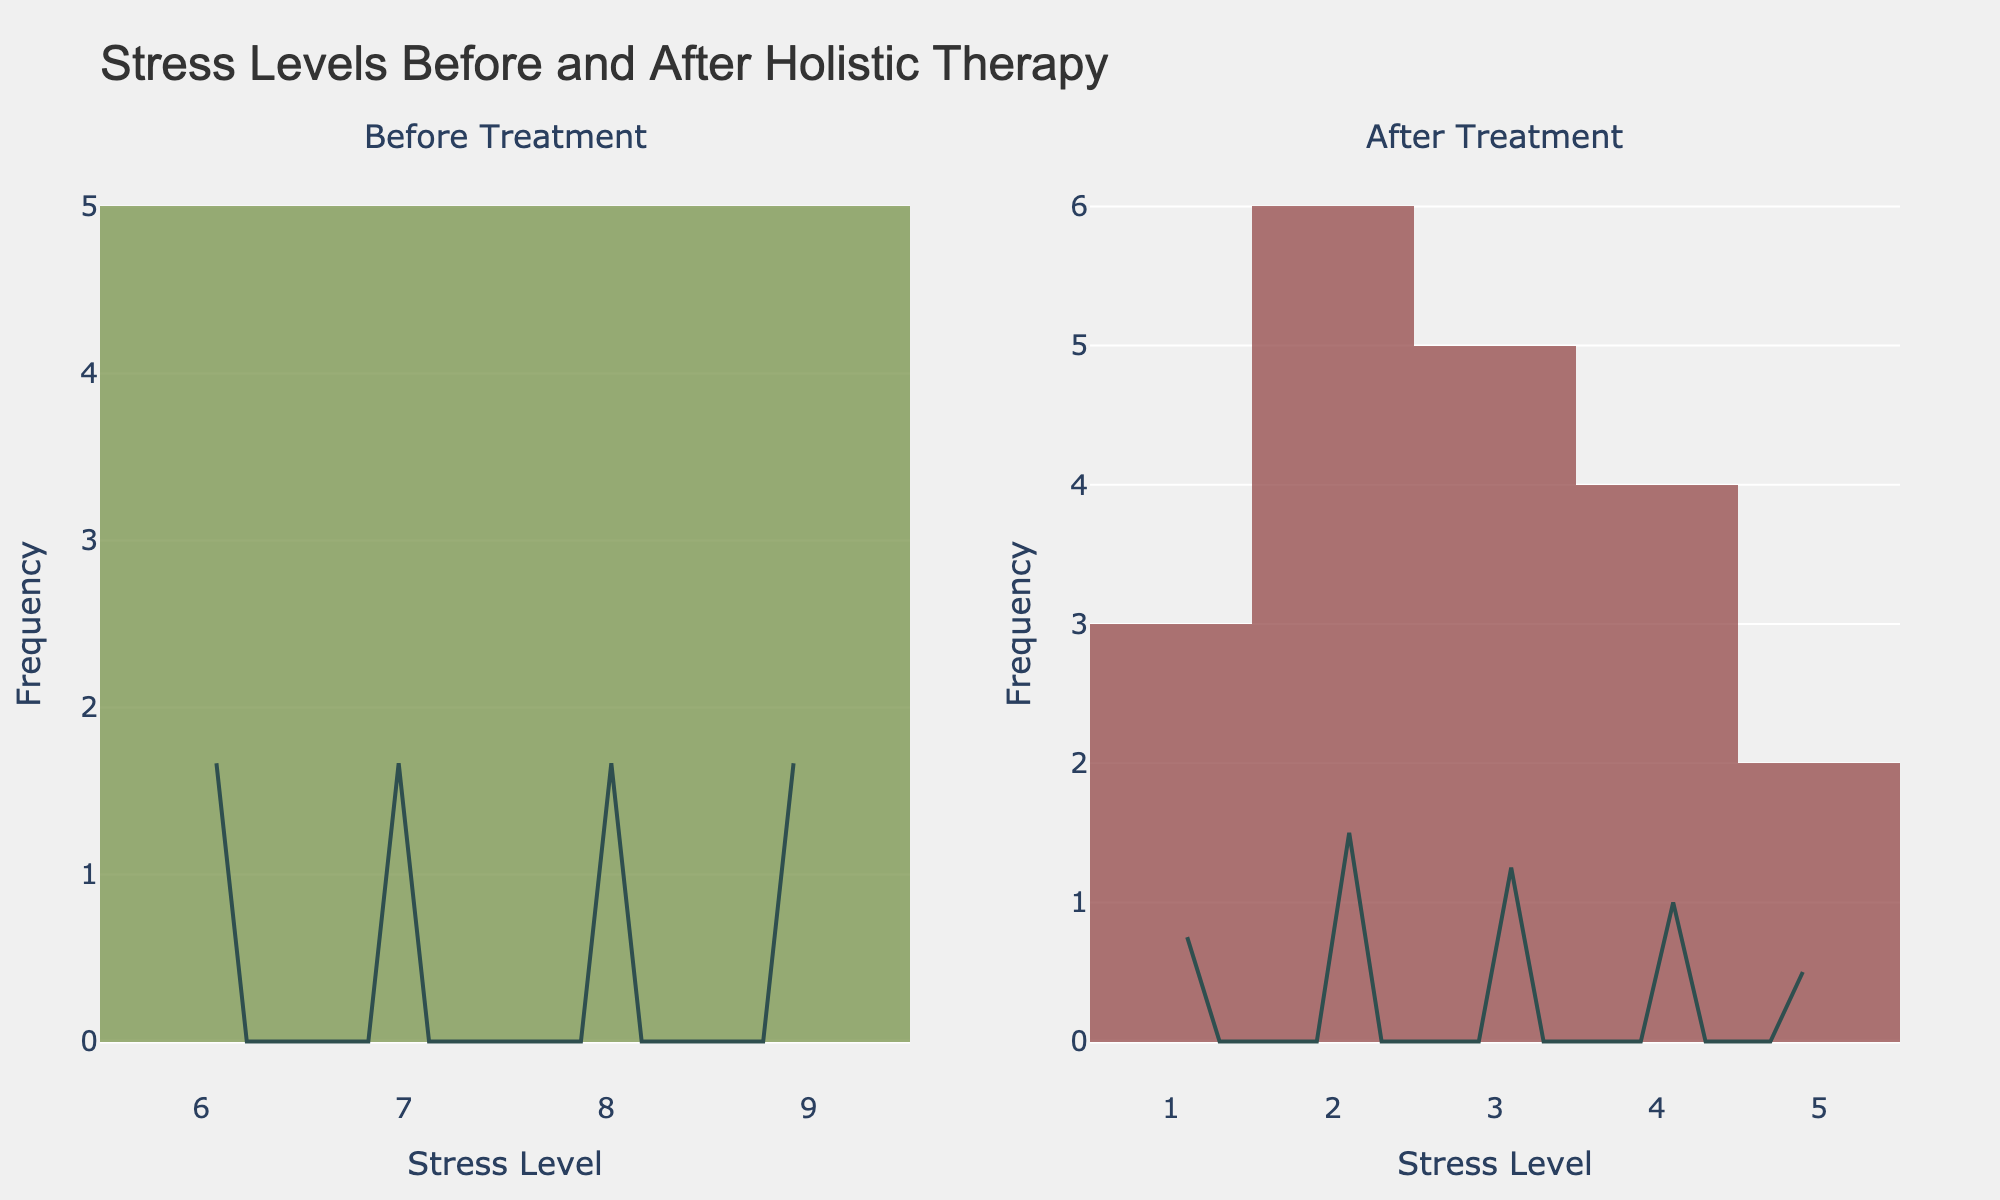What's the title of the figure? The title of the figure is prominently displayed at the top of the plot, and it indicates the subject of the visualization.
Answer: Stress Levels Before and After Holistic Therapy Which part of the plots represents the stress levels after treatment? The figure is divided into two parts, one for "Before Treatment" and one for "After Treatment". The part on the right side of the plot represents the data after the treatment.
Answer: The right side What is the predominant stress level before treatment based on the histogram? By examining the histogram on the "Before Treatment" side, we can see which stress level has the highest frequency.
Answer: 8 and 9 What does a KDE curve represent in this figure? The KDE (Kernel Density Estimate) curve provides a smoothed version of the histogram, showing the distribution density of the stress levels more clearly.
Answer: Distribution density Which stress levels show the most significant reduction after treatment? By comparing the histograms before and after treatment, we can determine which stress levels show the greatest decrease.
Answer: Levels 8 and 9 How do the shapes of the histograms before and after treatment compare? We examine the overall shape and spread of the histograms to see how the stress levels distribution has changed.
Answer: The histogram after treatment is more condensed towards lower stress levels What is the most common stress level after treatment? The histogram for "After Treatment" shows peaks that indicate the most common stress levels reported by clients.
Answer: 3 and 4 Is the stress level distribution more spread out before or after treatment? By looking at the spread of the histogram and KDE curves, we can determine which distribution is more uniform or spread out.
Answer: Before treatment What's the difference between the highest frequency bars before and after treatment? By finding the highest bars in both histograms and comparing their frequencies, we can see the change in predominant stress levels.
Answer: The highest frequency shifted from 8 and 9 before treatment to 3 and 4 after treatment How does the KDE curve help in understanding the data better? The KDE curve helps in visualizing the probability density function of the continuous stress level variable, offering a smoother view than the histogram bars alone.
Answer: It shows a smoothed distribution 